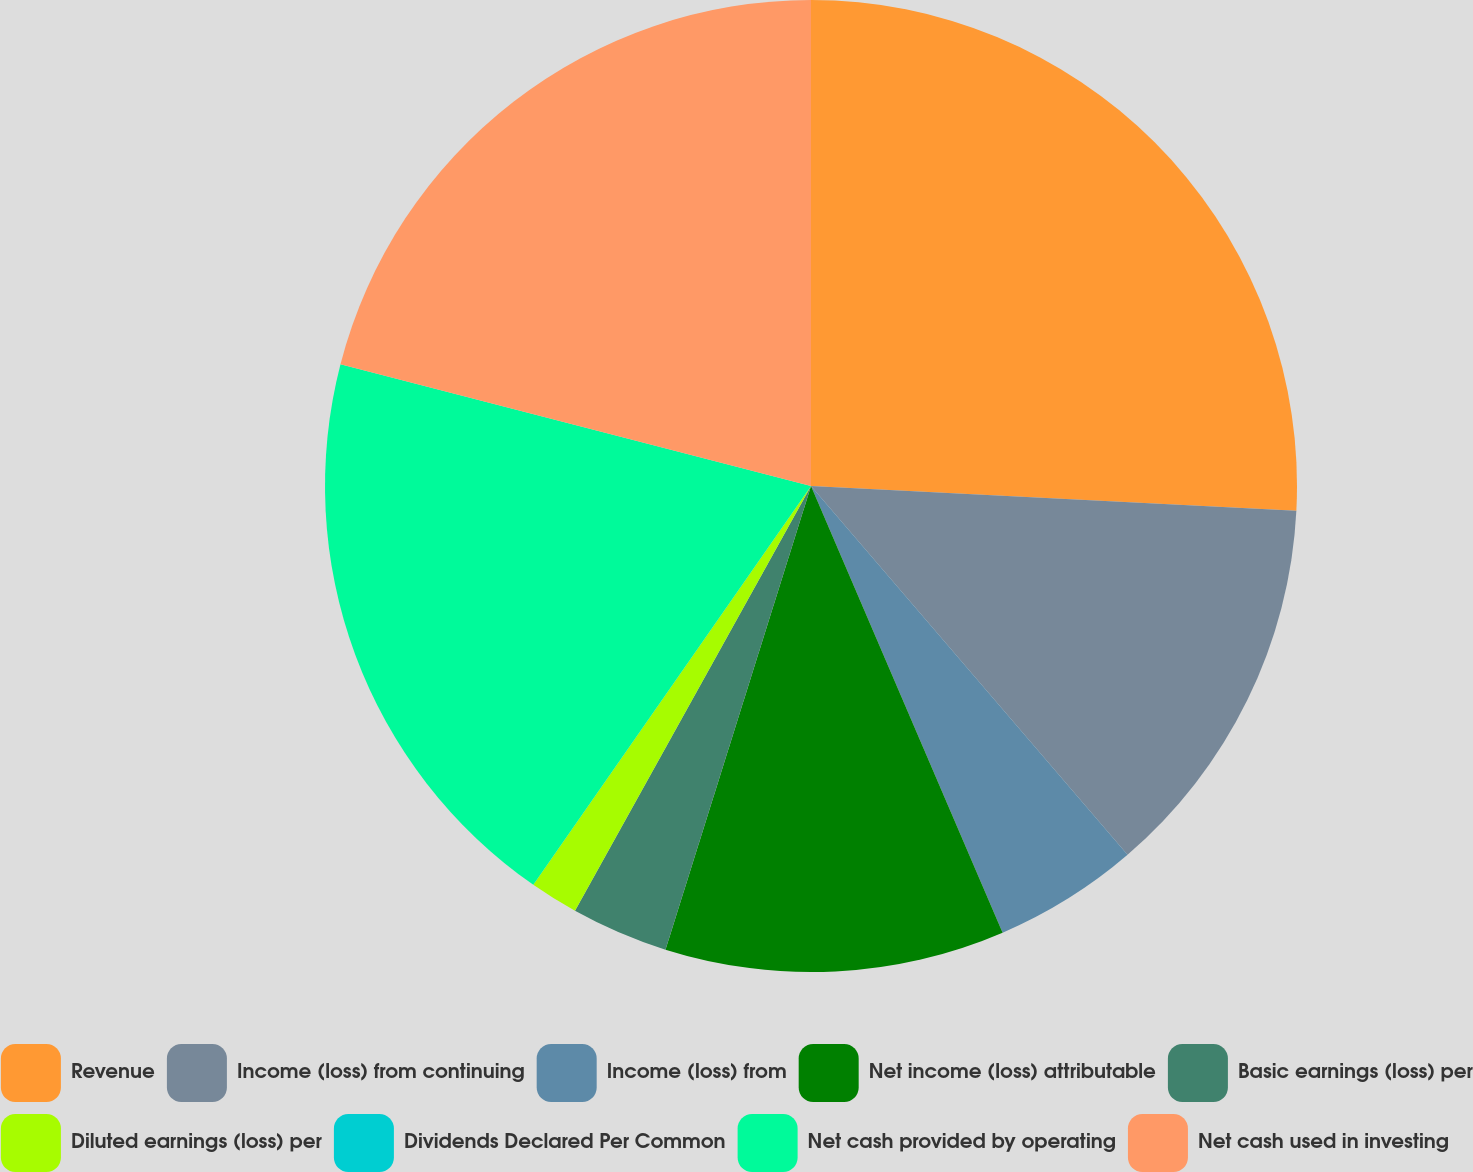<chart> <loc_0><loc_0><loc_500><loc_500><pie_chart><fcel>Revenue<fcel>Income (loss) from continuing<fcel>Income (loss) from<fcel>Net income (loss) attributable<fcel>Basic earnings (loss) per<fcel>Diluted earnings (loss) per<fcel>Dividends Declared Per Common<fcel>Net cash provided by operating<fcel>Net cash used in investing<nl><fcel>25.81%<fcel>12.9%<fcel>4.84%<fcel>11.29%<fcel>3.23%<fcel>1.61%<fcel>0.0%<fcel>19.35%<fcel>20.97%<nl></chart> 